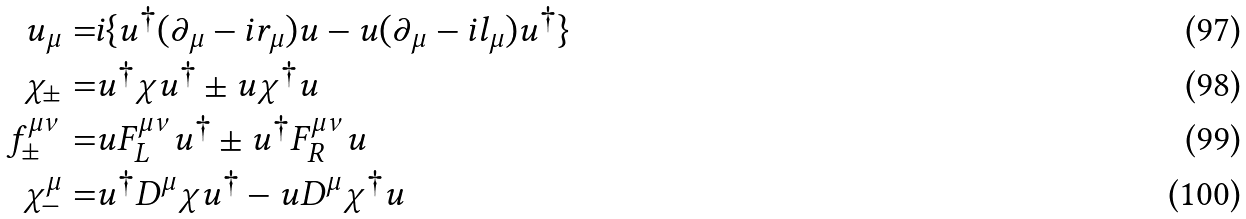Convert formula to latex. <formula><loc_0><loc_0><loc_500><loc_500>u _ { \mu } = & i \{ u ^ { \dag } ( \partial _ { \mu } - i r _ { \mu } ) u - u ( \partial _ { \mu } - i l _ { \mu } ) u ^ { \dag } \} \\ \chi _ { \pm } = & u ^ { \dag } \chi u ^ { \dag } \pm u \chi ^ { \dag } u \\ f _ { \pm } ^ { \mu \nu } = & u F _ { L } ^ { \mu \nu } u ^ { \dag } \pm u ^ { \dag } F _ { R } ^ { \mu \nu } u \\ \chi _ { - } ^ { \mu } = & u ^ { \dag } D ^ { \mu } \chi u ^ { \dag } - u D ^ { \mu } \chi ^ { \dag } u</formula> 